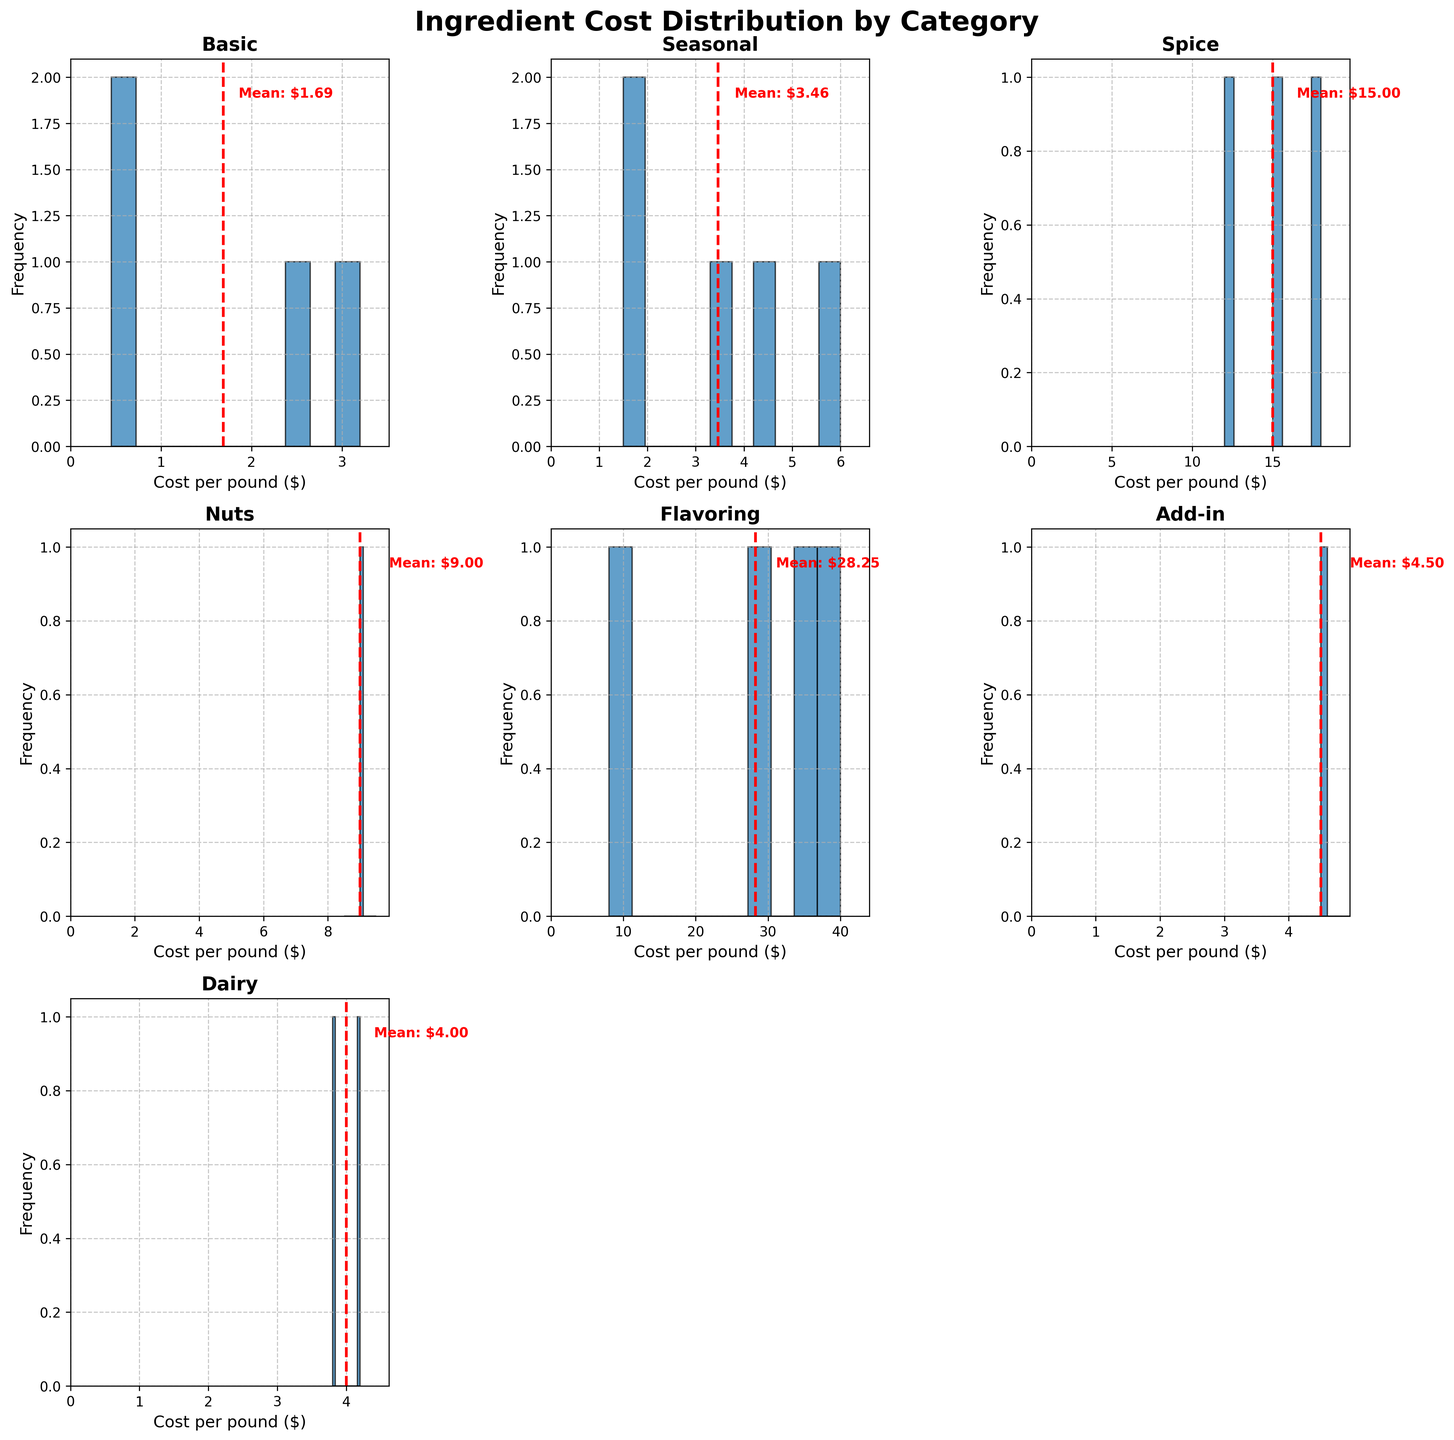What is the title of the figure? The title is displayed in large, bold font at the top of the figure.
Answer: "Ingredient Cost Distribution by Category" Which category has the highest mean cost indicated by a dashed red line? Looking at all the subplots, identify the histogram where the dashed red line indicating the mean is furthest to the right.
Answer: Flavoring What is the mean cost per pound of ingredients in the "Basic" category? Locate the subplot for "Basic" and check the dashed red line's label that shows the mean value.
Answer: $1.69 Which category shows the widest range of ingredient costs? Compare the x-axis ranges of each histogram to see which one has the largest span.
Answer: Flavoring How many categories do not have any data? Check the subplots to see if any have the text "No data" at the center.
Answer: 0 What is the cost per pound of the most expensive ingredient in the "Spice" category? Look for the highest value on the x-axis of the "Spice" histogram.
Answer: $18.00 Which category has ingredients that cost less than $1 per pound? Identify the histograms with bars to the left of the $1 mark on the x-axis.
Answer: Basic, Seasonal How does the price distribution of "Dairy" compare to "Add-in"? Compare the shape and spread of the histograms for "Dairy" and "Add-in".
Answer: Dairy has lower costs centered around $4, whereas Add-in costs are around $4.50 Is the mean cost of "Nuts" higher or lower than "Spice"? Compare the position of the dashed red lines in the "Nuts" and "Spice" subplots.
Answer: Lower What does the histogram for "Nuts" indicate about the distribution of costs for this category? Analyze the shape, spread, and central tendency of the "Nuts" histogram.
Answer: Costs are centered around $9.00 with a single peak 